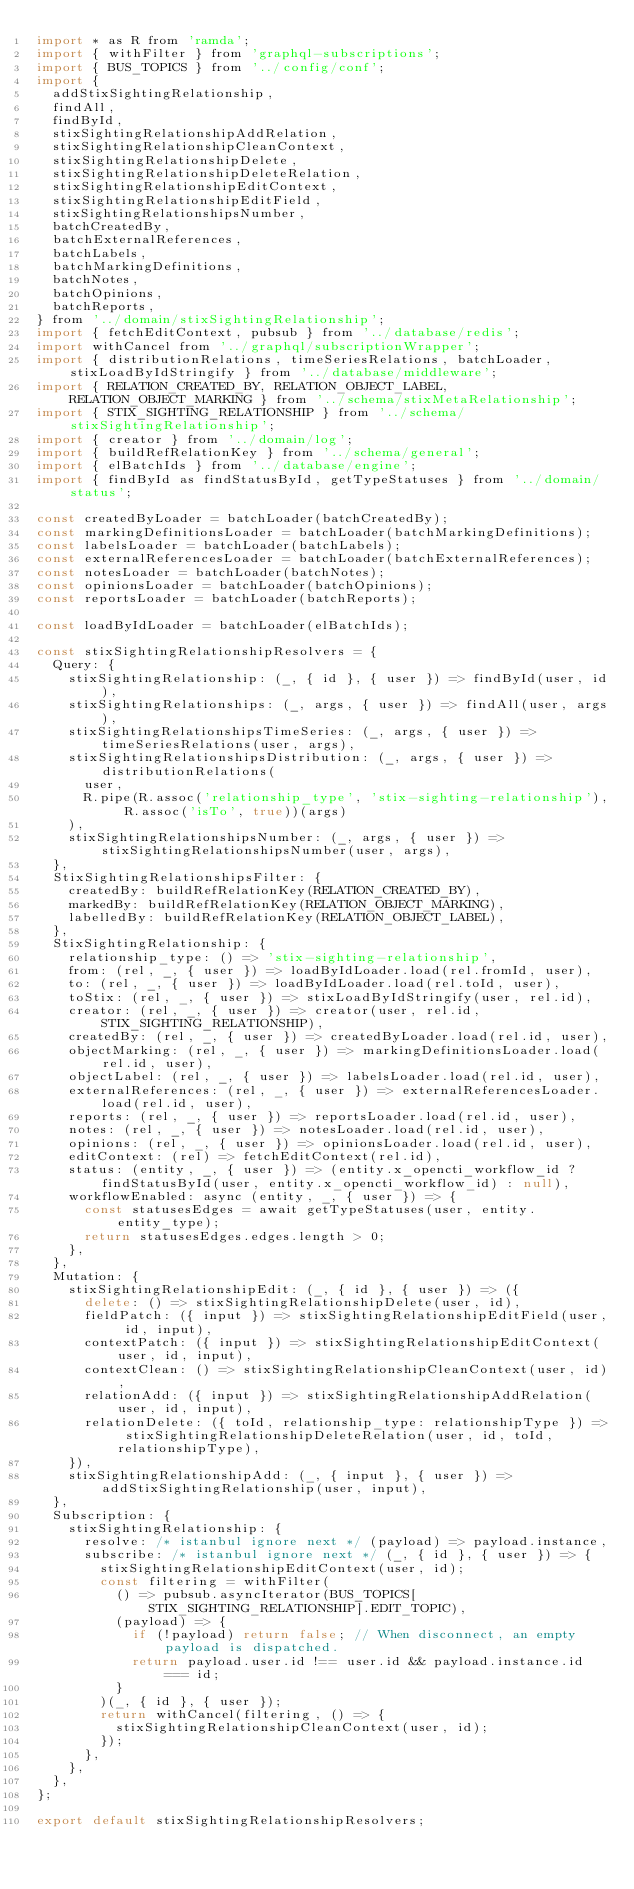<code> <loc_0><loc_0><loc_500><loc_500><_JavaScript_>import * as R from 'ramda';
import { withFilter } from 'graphql-subscriptions';
import { BUS_TOPICS } from '../config/conf';
import {
  addStixSightingRelationship,
  findAll,
  findById,
  stixSightingRelationshipAddRelation,
  stixSightingRelationshipCleanContext,
  stixSightingRelationshipDelete,
  stixSightingRelationshipDeleteRelation,
  stixSightingRelationshipEditContext,
  stixSightingRelationshipEditField,
  stixSightingRelationshipsNumber,
  batchCreatedBy,
  batchExternalReferences,
  batchLabels,
  batchMarkingDefinitions,
  batchNotes,
  batchOpinions,
  batchReports,
} from '../domain/stixSightingRelationship';
import { fetchEditContext, pubsub } from '../database/redis';
import withCancel from '../graphql/subscriptionWrapper';
import { distributionRelations, timeSeriesRelations, batchLoader, stixLoadByIdStringify } from '../database/middleware';
import { RELATION_CREATED_BY, RELATION_OBJECT_LABEL, RELATION_OBJECT_MARKING } from '../schema/stixMetaRelationship';
import { STIX_SIGHTING_RELATIONSHIP } from '../schema/stixSightingRelationship';
import { creator } from '../domain/log';
import { buildRefRelationKey } from '../schema/general';
import { elBatchIds } from '../database/engine';
import { findById as findStatusById, getTypeStatuses } from '../domain/status';

const createdByLoader = batchLoader(batchCreatedBy);
const markingDefinitionsLoader = batchLoader(batchMarkingDefinitions);
const labelsLoader = batchLoader(batchLabels);
const externalReferencesLoader = batchLoader(batchExternalReferences);
const notesLoader = batchLoader(batchNotes);
const opinionsLoader = batchLoader(batchOpinions);
const reportsLoader = batchLoader(batchReports);

const loadByIdLoader = batchLoader(elBatchIds);

const stixSightingRelationshipResolvers = {
  Query: {
    stixSightingRelationship: (_, { id }, { user }) => findById(user, id),
    stixSightingRelationships: (_, args, { user }) => findAll(user, args),
    stixSightingRelationshipsTimeSeries: (_, args, { user }) => timeSeriesRelations(user, args),
    stixSightingRelationshipsDistribution: (_, args, { user }) => distributionRelations(
      user,
      R.pipe(R.assoc('relationship_type', 'stix-sighting-relationship'), R.assoc('isTo', true))(args)
    ),
    stixSightingRelationshipsNumber: (_, args, { user }) => stixSightingRelationshipsNumber(user, args),
  },
  StixSightingRelationshipsFilter: {
    createdBy: buildRefRelationKey(RELATION_CREATED_BY),
    markedBy: buildRefRelationKey(RELATION_OBJECT_MARKING),
    labelledBy: buildRefRelationKey(RELATION_OBJECT_LABEL),
  },
  StixSightingRelationship: {
    relationship_type: () => 'stix-sighting-relationship',
    from: (rel, _, { user }) => loadByIdLoader.load(rel.fromId, user),
    to: (rel, _, { user }) => loadByIdLoader.load(rel.toId, user),
    toStix: (rel, _, { user }) => stixLoadByIdStringify(user, rel.id),
    creator: (rel, _, { user }) => creator(user, rel.id, STIX_SIGHTING_RELATIONSHIP),
    createdBy: (rel, _, { user }) => createdByLoader.load(rel.id, user),
    objectMarking: (rel, _, { user }) => markingDefinitionsLoader.load(rel.id, user),
    objectLabel: (rel, _, { user }) => labelsLoader.load(rel.id, user),
    externalReferences: (rel, _, { user }) => externalReferencesLoader.load(rel.id, user),
    reports: (rel, _, { user }) => reportsLoader.load(rel.id, user),
    notes: (rel, _, { user }) => notesLoader.load(rel.id, user),
    opinions: (rel, _, { user }) => opinionsLoader.load(rel.id, user),
    editContext: (rel) => fetchEditContext(rel.id),
    status: (entity, _, { user }) => (entity.x_opencti_workflow_id ? findStatusById(user, entity.x_opencti_workflow_id) : null),
    workflowEnabled: async (entity, _, { user }) => {
      const statusesEdges = await getTypeStatuses(user, entity.entity_type);
      return statusesEdges.edges.length > 0;
    },
  },
  Mutation: {
    stixSightingRelationshipEdit: (_, { id }, { user }) => ({
      delete: () => stixSightingRelationshipDelete(user, id),
      fieldPatch: ({ input }) => stixSightingRelationshipEditField(user, id, input),
      contextPatch: ({ input }) => stixSightingRelationshipEditContext(user, id, input),
      contextClean: () => stixSightingRelationshipCleanContext(user, id),
      relationAdd: ({ input }) => stixSightingRelationshipAddRelation(user, id, input),
      relationDelete: ({ toId, relationship_type: relationshipType }) => stixSightingRelationshipDeleteRelation(user, id, toId, relationshipType),
    }),
    stixSightingRelationshipAdd: (_, { input }, { user }) => addStixSightingRelationship(user, input),
  },
  Subscription: {
    stixSightingRelationship: {
      resolve: /* istanbul ignore next */ (payload) => payload.instance,
      subscribe: /* istanbul ignore next */ (_, { id }, { user }) => {
        stixSightingRelationshipEditContext(user, id);
        const filtering = withFilter(
          () => pubsub.asyncIterator(BUS_TOPICS[STIX_SIGHTING_RELATIONSHIP].EDIT_TOPIC),
          (payload) => {
            if (!payload) return false; // When disconnect, an empty payload is dispatched.
            return payload.user.id !== user.id && payload.instance.id === id;
          }
        )(_, { id }, { user });
        return withCancel(filtering, () => {
          stixSightingRelationshipCleanContext(user, id);
        });
      },
    },
  },
};

export default stixSightingRelationshipResolvers;
</code> 